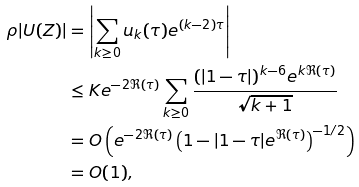Convert formula to latex. <formula><loc_0><loc_0><loc_500><loc_500>\rho | U ( Z ) | & = \left | \sum _ { k \geq 0 } u _ { k } ( \tau ) e ^ { ( k - 2 ) \tau } \right | \\ & \leq K e ^ { - 2 \Re ( \tau ) } \sum _ { k \geq 0 } \frac { ( | 1 - \tau | ) ^ { k - 6 } e ^ { k \Re ( \tau ) } } { \sqrt { k + 1 } } \\ & = O \left ( e ^ { - 2 \Re ( \tau ) } \left ( 1 - | 1 - \tau | e ^ { \Re ( \tau ) } \right ) ^ { - 1 / 2 } \right ) \\ & = O ( 1 ) ,</formula> 